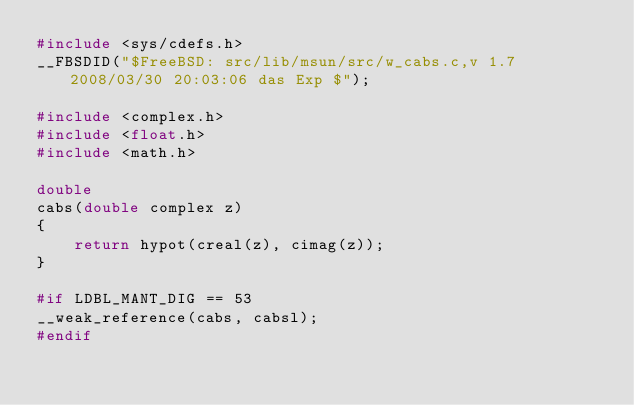Convert code to text. <code><loc_0><loc_0><loc_500><loc_500><_C_>#include <sys/cdefs.h>
__FBSDID("$FreeBSD: src/lib/msun/src/w_cabs.c,v 1.7 2008/03/30 20:03:06 das Exp $");

#include <complex.h>
#include <float.h>
#include <math.h>

double
cabs(double complex z)
{
	return hypot(creal(z), cimag(z));
}

#if LDBL_MANT_DIG == 53
__weak_reference(cabs, cabsl);
#endif
</code> 